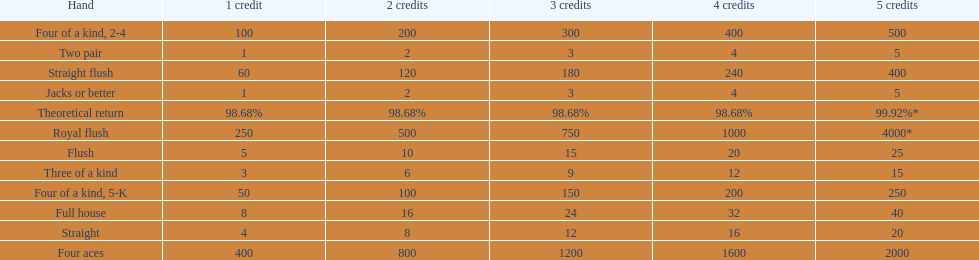What is the total amount of a 3 credit straight flush? 180. Could you parse the entire table? {'header': ['Hand', '1 credit', '2 credits', '3 credits', '4 credits', '5 credits'], 'rows': [['Four of a kind, 2-4', '100', '200', '300', '400', '500'], ['Two pair', '1', '2', '3', '4', '5'], ['Straight flush', '60', '120', '180', '240', '400'], ['Jacks or better', '1', '2', '3', '4', '5'], ['Theoretical return', '98.68%', '98.68%', '98.68%', '98.68%', '99.92%*'], ['Royal flush', '250', '500', '750', '1000', '4000*'], ['Flush', '5', '10', '15', '20', '25'], ['Three of a kind', '3', '6', '9', '12', '15'], ['Four of a kind, 5-K', '50', '100', '150', '200', '250'], ['Full house', '8', '16', '24', '32', '40'], ['Straight', '4', '8', '12', '16', '20'], ['Four aces', '400', '800', '1200', '1600', '2000']]} 